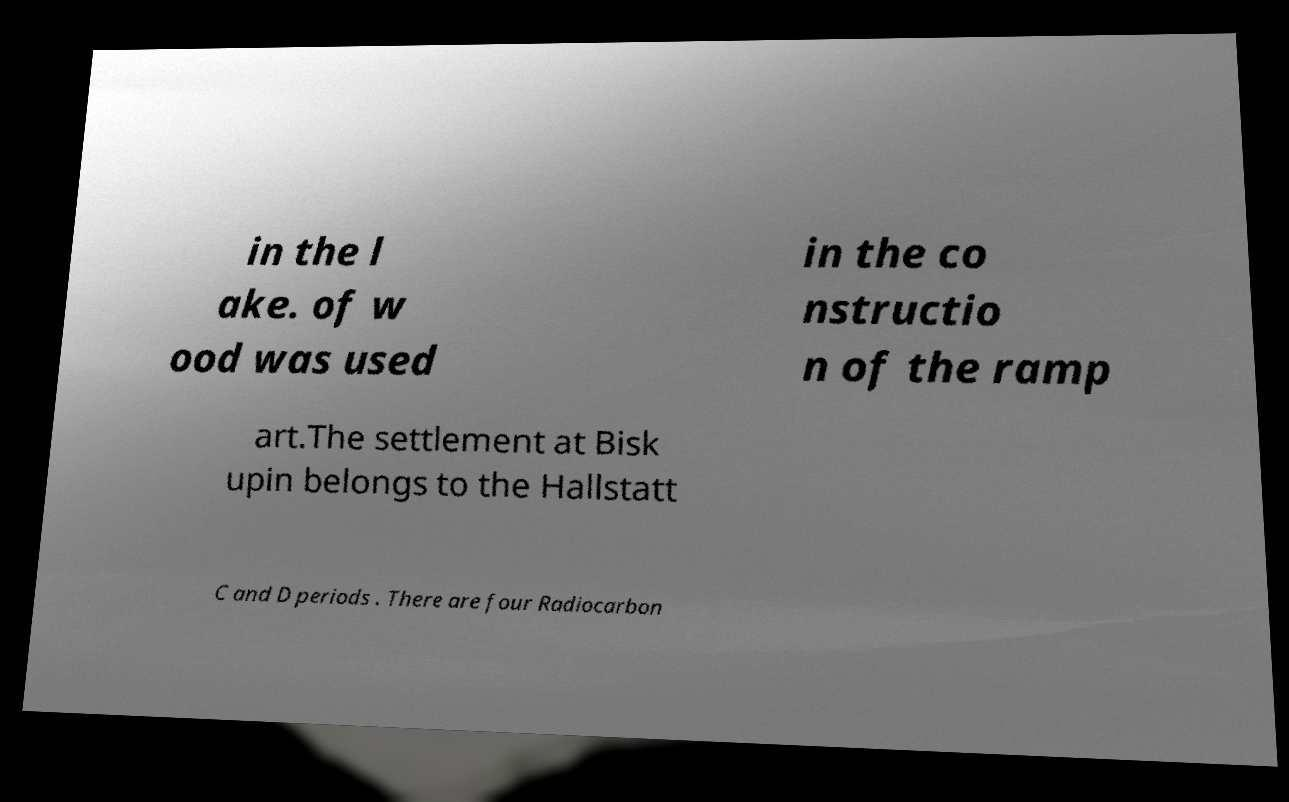There's text embedded in this image that I need extracted. Can you transcribe it verbatim? in the l ake. of w ood was used in the co nstructio n of the ramp art.The settlement at Bisk upin belongs to the Hallstatt C and D periods . There are four Radiocarbon 